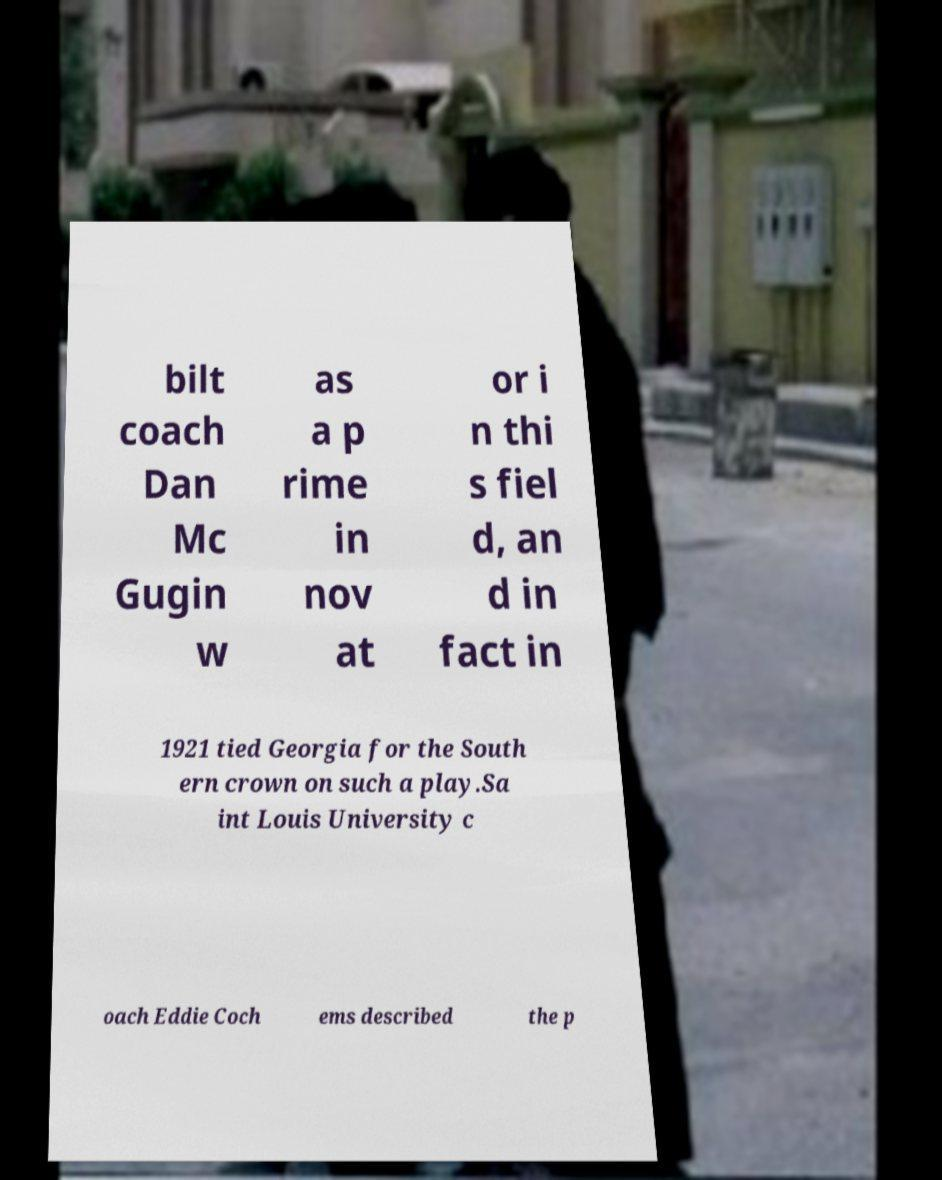For documentation purposes, I need the text within this image transcribed. Could you provide that? bilt coach Dan Mc Gugin w as a p rime in nov at or i n thi s fiel d, an d in fact in 1921 tied Georgia for the South ern crown on such a play.Sa int Louis University c oach Eddie Coch ems described the p 